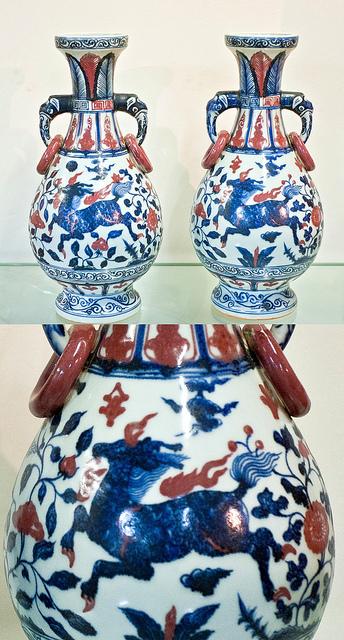How many vases are shown?
Be succinct. 3. What animal is on the vase?
Write a very short answer. Horse. Is the vase white?
Answer briefly. Yes. Is this expensive?
Keep it brief. Yes. What animal is depicted on the vase?
Write a very short answer. Horse. 